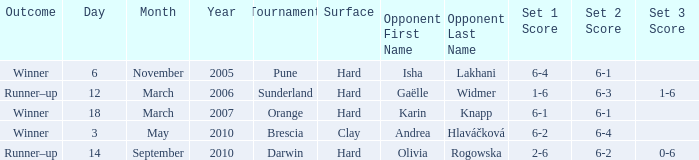What was the score of the tournament against Isha Lakhani? 6-4 6-1. 